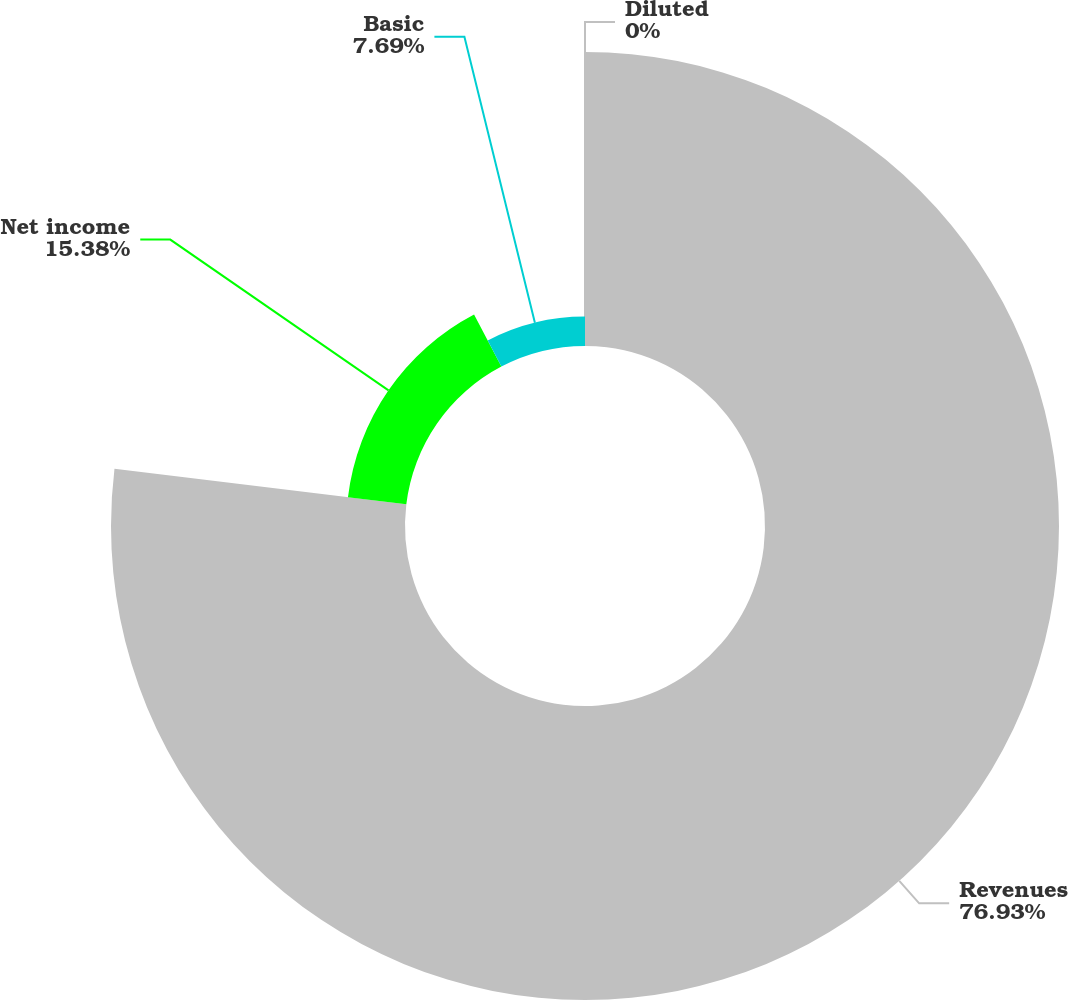<chart> <loc_0><loc_0><loc_500><loc_500><pie_chart><fcel>Revenues<fcel>Net income<fcel>Basic<fcel>Diluted<nl><fcel>76.92%<fcel>15.38%<fcel>7.69%<fcel>0.0%<nl></chart> 